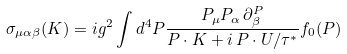Convert formula to latex. <formula><loc_0><loc_0><loc_500><loc_500>\sigma _ { \mu \alpha \beta } ( K ) = i g ^ { 2 } \int d ^ { 4 } P \frac { P _ { \mu } P _ { \alpha } \, \partial ^ { P } _ { \beta } } { P \cdot K + i \, P \cdot U / \tau ^ { * } } f _ { 0 } ( P )</formula> 